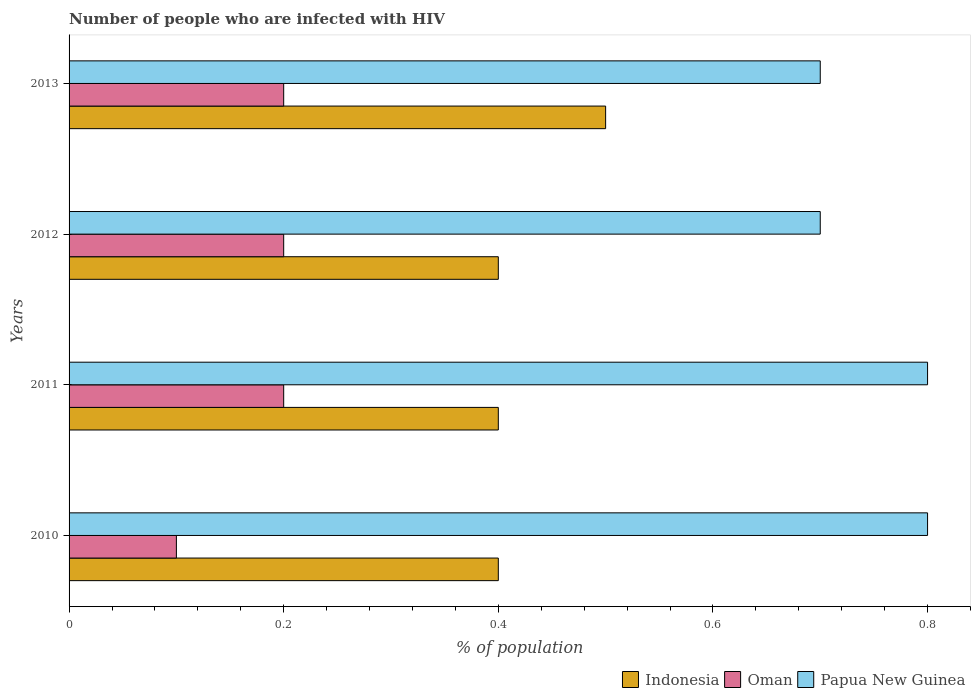How many groups of bars are there?
Provide a short and direct response. 4. How many bars are there on the 2nd tick from the top?
Provide a short and direct response. 3. How many bars are there on the 3rd tick from the bottom?
Your answer should be compact. 3. What is the label of the 1st group of bars from the top?
Your answer should be very brief. 2013. Across all years, what is the maximum percentage of HIV infected population in in Oman?
Ensure brevity in your answer.  0.2. In which year was the percentage of HIV infected population in in Oman maximum?
Give a very brief answer. 2011. What is the difference between the percentage of HIV infected population in in Papua New Guinea in 2010 and that in 2012?
Ensure brevity in your answer.  0.1. What is the difference between the percentage of HIV infected population in in Indonesia in 2010 and the percentage of HIV infected population in in Papua New Guinea in 2012?
Your answer should be very brief. -0.3. What is the average percentage of HIV infected population in in Oman per year?
Give a very brief answer. 0.17. In how many years, is the percentage of HIV infected population in in Oman greater than 0.24000000000000002 %?
Your answer should be compact. 0. Is the percentage of HIV infected population in in Papua New Guinea in 2012 less than that in 2013?
Your answer should be compact. No. Is the difference between the percentage of HIV infected population in in Papua New Guinea in 2010 and 2013 greater than the difference between the percentage of HIV infected population in in Indonesia in 2010 and 2013?
Provide a succinct answer. Yes. What is the difference between the highest and the second highest percentage of HIV infected population in in Oman?
Your answer should be very brief. 0. In how many years, is the percentage of HIV infected population in in Oman greater than the average percentage of HIV infected population in in Oman taken over all years?
Provide a succinct answer. 3. Is the sum of the percentage of HIV infected population in in Oman in 2010 and 2012 greater than the maximum percentage of HIV infected population in in Indonesia across all years?
Give a very brief answer. No. What does the 1st bar from the top in 2013 represents?
Your answer should be very brief. Papua New Guinea. What does the 2nd bar from the bottom in 2013 represents?
Give a very brief answer. Oman. Is it the case that in every year, the sum of the percentage of HIV infected population in in Oman and percentage of HIV infected population in in Papua New Guinea is greater than the percentage of HIV infected population in in Indonesia?
Give a very brief answer. Yes. How many bars are there?
Your answer should be compact. 12. Are all the bars in the graph horizontal?
Your answer should be very brief. Yes. Does the graph contain any zero values?
Provide a succinct answer. No. How many legend labels are there?
Provide a short and direct response. 3. What is the title of the graph?
Your answer should be very brief. Number of people who are infected with HIV. What is the label or title of the X-axis?
Your answer should be compact. % of population. What is the label or title of the Y-axis?
Your answer should be very brief. Years. What is the % of population in Indonesia in 2010?
Ensure brevity in your answer.  0.4. What is the % of population of Oman in 2010?
Your answer should be very brief. 0.1. What is the % of population in Papua New Guinea in 2010?
Provide a short and direct response. 0.8. What is the % of population in Indonesia in 2011?
Keep it short and to the point. 0.4. What is the % of population in Papua New Guinea in 2011?
Provide a short and direct response. 0.8. What is the % of population of Oman in 2012?
Offer a terse response. 0.2. What is the % of population in Papua New Guinea in 2012?
Give a very brief answer. 0.7. What is the % of population of Indonesia in 2013?
Give a very brief answer. 0.5. What is the % of population of Oman in 2013?
Keep it short and to the point. 0.2. What is the % of population in Papua New Guinea in 2013?
Provide a succinct answer. 0.7. Across all years, what is the maximum % of population in Indonesia?
Your answer should be very brief. 0.5. Across all years, what is the maximum % of population of Papua New Guinea?
Your answer should be very brief. 0.8. Across all years, what is the minimum % of population in Indonesia?
Your answer should be very brief. 0.4. Across all years, what is the minimum % of population of Papua New Guinea?
Keep it short and to the point. 0.7. What is the total % of population of Indonesia in the graph?
Provide a short and direct response. 1.7. What is the total % of population of Papua New Guinea in the graph?
Make the answer very short. 3. What is the difference between the % of population of Indonesia in 2010 and that in 2011?
Provide a succinct answer. 0. What is the difference between the % of population in Indonesia in 2010 and that in 2012?
Provide a short and direct response. 0. What is the difference between the % of population in Oman in 2010 and that in 2012?
Your answer should be compact. -0.1. What is the difference between the % of population of Papua New Guinea in 2010 and that in 2012?
Offer a very short reply. 0.1. What is the difference between the % of population in Oman in 2010 and that in 2013?
Offer a very short reply. -0.1. What is the difference between the % of population in Papua New Guinea in 2010 and that in 2013?
Give a very brief answer. 0.1. What is the difference between the % of population in Oman in 2011 and that in 2012?
Keep it short and to the point. 0. What is the difference between the % of population of Indonesia in 2011 and that in 2013?
Offer a very short reply. -0.1. What is the difference between the % of population in Oman in 2012 and that in 2013?
Offer a terse response. 0. What is the difference between the % of population of Indonesia in 2010 and the % of population of Oman in 2011?
Keep it short and to the point. 0.2. What is the difference between the % of population in Indonesia in 2010 and the % of population in Papua New Guinea in 2011?
Provide a succinct answer. -0.4. What is the difference between the % of population in Oman in 2010 and the % of population in Papua New Guinea in 2011?
Make the answer very short. -0.7. What is the difference between the % of population of Indonesia in 2010 and the % of population of Papua New Guinea in 2012?
Provide a succinct answer. -0.3. What is the difference between the % of population of Indonesia in 2010 and the % of population of Papua New Guinea in 2013?
Your response must be concise. -0.3. What is the difference between the % of population in Oman in 2010 and the % of population in Papua New Guinea in 2013?
Offer a very short reply. -0.6. What is the difference between the % of population in Indonesia in 2011 and the % of population in Oman in 2012?
Offer a terse response. 0.2. What is the difference between the % of population of Oman in 2011 and the % of population of Papua New Guinea in 2012?
Keep it short and to the point. -0.5. What is the difference between the % of population of Indonesia in 2011 and the % of population of Oman in 2013?
Offer a terse response. 0.2. What is the difference between the % of population of Indonesia in 2011 and the % of population of Papua New Guinea in 2013?
Your answer should be compact. -0.3. What is the difference between the % of population in Indonesia in 2012 and the % of population in Papua New Guinea in 2013?
Ensure brevity in your answer.  -0.3. What is the average % of population of Indonesia per year?
Offer a terse response. 0.42. What is the average % of population of Oman per year?
Give a very brief answer. 0.17. What is the average % of population in Papua New Guinea per year?
Provide a succinct answer. 0.75. In the year 2010, what is the difference between the % of population of Indonesia and % of population of Papua New Guinea?
Provide a short and direct response. -0.4. In the year 2012, what is the difference between the % of population of Indonesia and % of population of Papua New Guinea?
Offer a very short reply. -0.3. In the year 2012, what is the difference between the % of population in Oman and % of population in Papua New Guinea?
Provide a succinct answer. -0.5. In the year 2013, what is the difference between the % of population of Indonesia and % of population of Papua New Guinea?
Provide a succinct answer. -0.2. In the year 2013, what is the difference between the % of population of Oman and % of population of Papua New Guinea?
Your answer should be compact. -0.5. What is the ratio of the % of population in Indonesia in 2010 to that in 2011?
Provide a short and direct response. 1. What is the ratio of the % of population of Oman in 2010 to that in 2011?
Your response must be concise. 0.5. What is the ratio of the % of population of Papua New Guinea in 2010 to that in 2011?
Offer a terse response. 1. What is the ratio of the % of population in Oman in 2010 to that in 2012?
Give a very brief answer. 0.5. What is the ratio of the % of population in Papua New Guinea in 2010 to that in 2012?
Provide a succinct answer. 1.14. What is the ratio of the % of population of Indonesia in 2010 to that in 2013?
Provide a succinct answer. 0.8. What is the ratio of the % of population in Papua New Guinea in 2011 to that in 2012?
Offer a terse response. 1.14. What is the ratio of the % of population in Papua New Guinea in 2011 to that in 2013?
Your answer should be compact. 1.14. What is the ratio of the % of population of Papua New Guinea in 2012 to that in 2013?
Give a very brief answer. 1. What is the difference between the highest and the lowest % of population in Oman?
Offer a very short reply. 0.1. What is the difference between the highest and the lowest % of population in Papua New Guinea?
Ensure brevity in your answer.  0.1. 